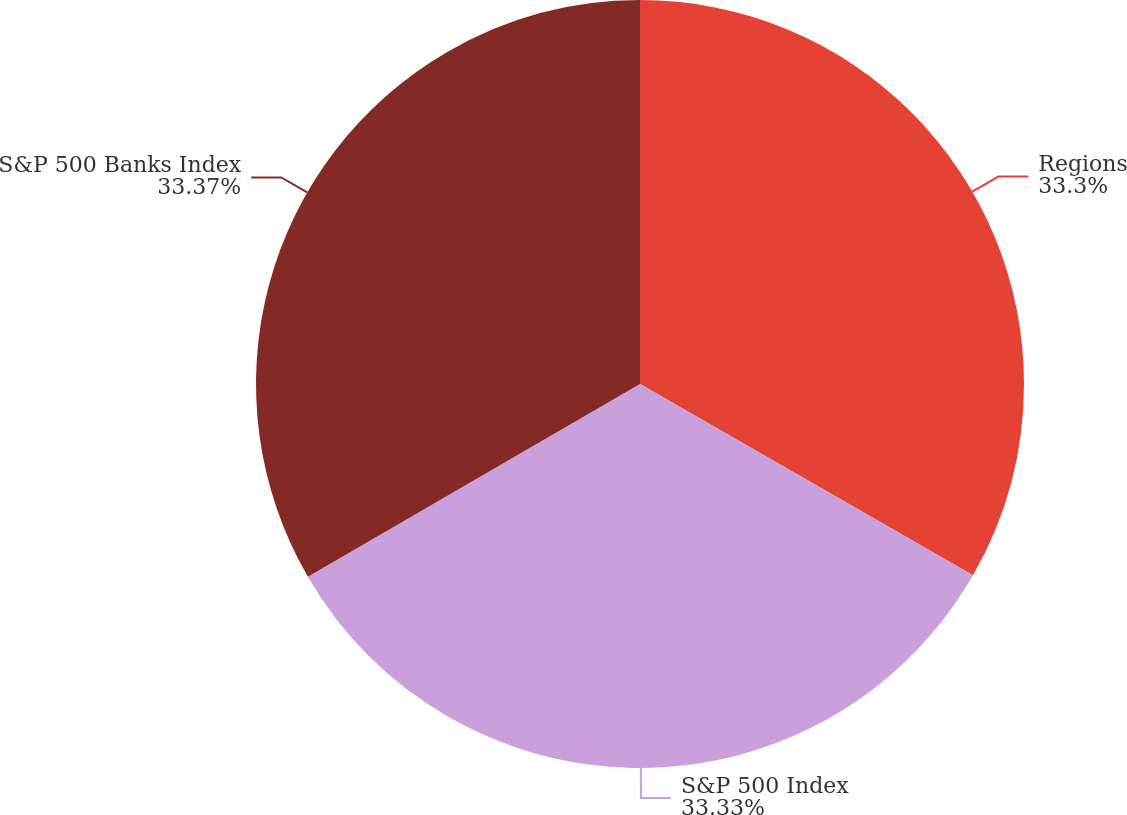Convert chart to OTSL. <chart><loc_0><loc_0><loc_500><loc_500><pie_chart><fcel>Regions<fcel>S&P 500 Index<fcel>S&P 500 Banks Index<nl><fcel>33.3%<fcel>33.33%<fcel>33.37%<nl></chart> 